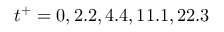Convert formula to latex. <formula><loc_0><loc_0><loc_500><loc_500>t ^ { + } = 0 , 2 . 2 , 4 . 4 , 1 1 . 1 , 2 2 . 3</formula> 